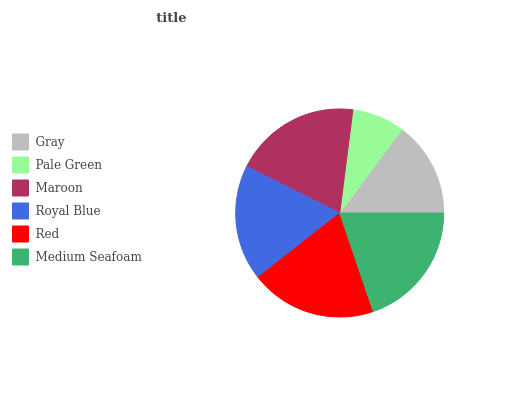Is Pale Green the minimum?
Answer yes or no. Yes. Is Medium Seafoam the maximum?
Answer yes or no. Yes. Is Maroon the minimum?
Answer yes or no. No. Is Maroon the maximum?
Answer yes or no. No. Is Maroon greater than Pale Green?
Answer yes or no. Yes. Is Pale Green less than Maroon?
Answer yes or no. Yes. Is Pale Green greater than Maroon?
Answer yes or no. No. Is Maroon less than Pale Green?
Answer yes or no. No. Is Red the high median?
Answer yes or no. Yes. Is Royal Blue the low median?
Answer yes or no. Yes. Is Gray the high median?
Answer yes or no. No. Is Medium Seafoam the low median?
Answer yes or no. No. 